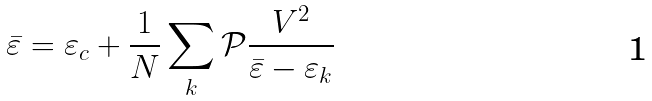Convert formula to latex. <formula><loc_0><loc_0><loc_500><loc_500>\bar { \varepsilon } = \varepsilon _ { c } + \frac { 1 } { N } \sum _ { k } \mathcal { P } \frac { V ^ { 2 } } { \bar { \varepsilon } - \varepsilon _ { k } }</formula> 